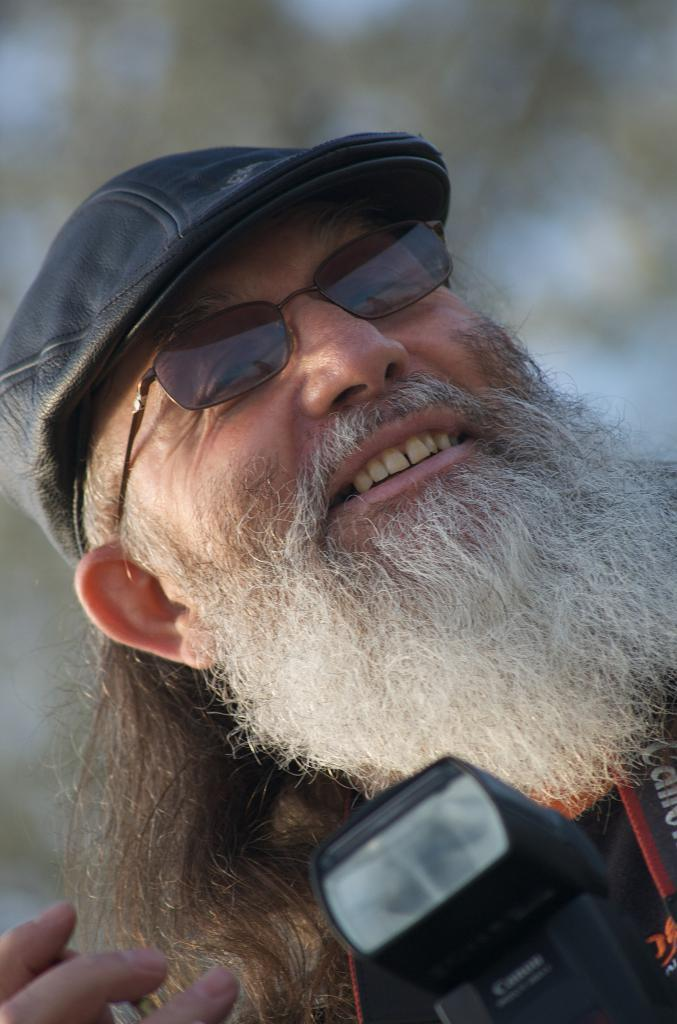Who is present in the image? There is a man in the image. What is the man doing in the image? The man is smiling in the image. What object is located at the bottom of the image? There is a camera at the bottom of the image. Can you describe the background of the image? The background of the image is blurred. Is there a beggar asking for money in the image? There is no beggar present in the image. What part of the man's brain can be seen in the image? The image does not show any part of the man's brain; it only shows his face and upper body. 